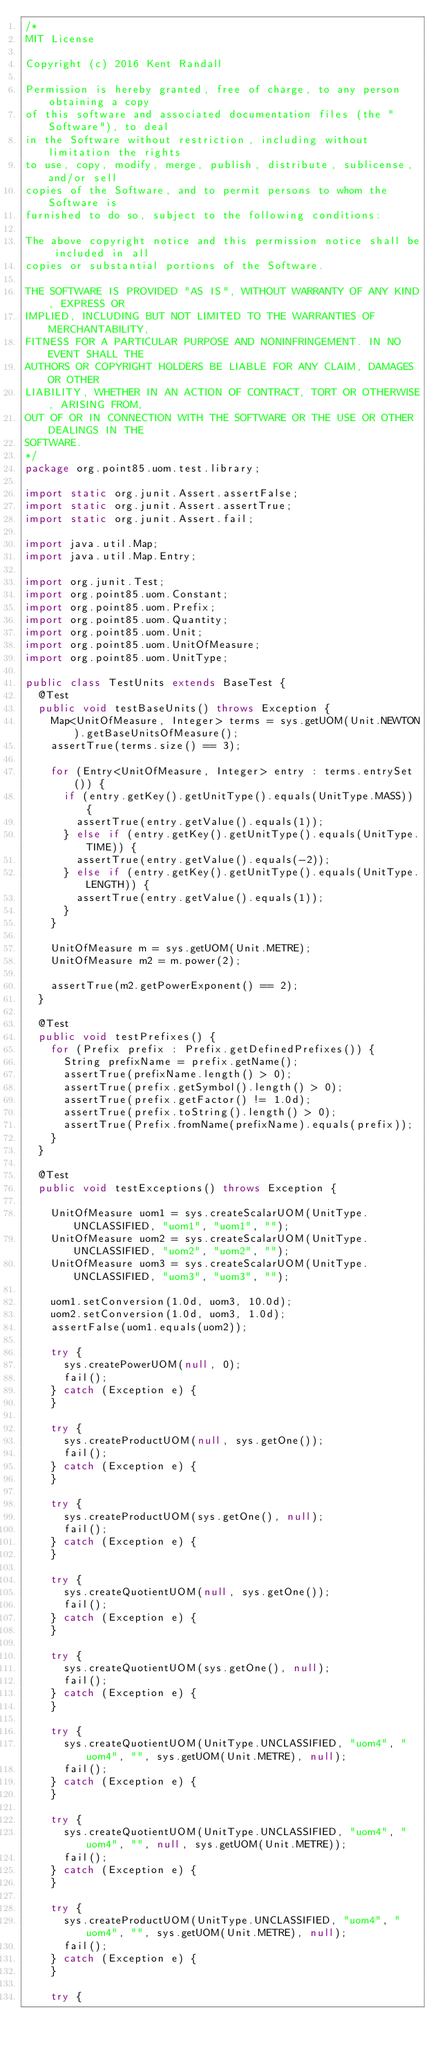Convert code to text. <code><loc_0><loc_0><loc_500><loc_500><_Java_>/*
MIT License

Copyright (c) 2016 Kent Randall

Permission is hereby granted, free of charge, to any person obtaining a copy
of this software and associated documentation files (the "Software"), to deal
in the Software without restriction, including without limitation the rights
to use, copy, modify, merge, publish, distribute, sublicense, and/or sell
copies of the Software, and to permit persons to whom the Software is
furnished to do so, subject to the following conditions:

The above copyright notice and this permission notice shall be included in all
copies or substantial portions of the Software.

THE SOFTWARE IS PROVIDED "AS IS", WITHOUT WARRANTY OF ANY KIND, EXPRESS OR
IMPLIED, INCLUDING BUT NOT LIMITED TO THE WARRANTIES OF MERCHANTABILITY,
FITNESS FOR A PARTICULAR PURPOSE AND NONINFRINGEMENT. IN NO EVENT SHALL THE
AUTHORS OR COPYRIGHT HOLDERS BE LIABLE FOR ANY CLAIM, DAMAGES OR OTHER
LIABILITY, WHETHER IN AN ACTION OF CONTRACT, TORT OR OTHERWISE, ARISING FROM,
OUT OF OR IN CONNECTION WITH THE SOFTWARE OR THE USE OR OTHER DEALINGS IN THE
SOFTWARE.
*/
package org.point85.uom.test.library;

import static org.junit.Assert.assertFalse;
import static org.junit.Assert.assertTrue;
import static org.junit.Assert.fail;

import java.util.Map;
import java.util.Map.Entry;

import org.junit.Test;
import org.point85.uom.Constant;
import org.point85.uom.Prefix;
import org.point85.uom.Quantity;
import org.point85.uom.Unit;
import org.point85.uom.UnitOfMeasure;
import org.point85.uom.UnitType;

public class TestUnits extends BaseTest {
	@Test
	public void testBaseUnits() throws Exception {
		Map<UnitOfMeasure, Integer> terms = sys.getUOM(Unit.NEWTON).getBaseUnitsOfMeasure();
		assertTrue(terms.size() == 3);

		for (Entry<UnitOfMeasure, Integer> entry : terms.entrySet()) {
			if (entry.getKey().getUnitType().equals(UnitType.MASS)) {
				assertTrue(entry.getValue().equals(1));
			} else if (entry.getKey().getUnitType().equals(UnitType.TIME)) {
				assertTrue(entry.getValue().equals(-2));
			} else if (entry.getKey().getUnitType().equals(UnitType.LENGTH)) {
				assertTrue(entry.getValue().equals(1));
			}
		}

		UnitOfMeasure m = sys.getUOM(Unit.METRE);
		UnitOfMeasure m2 = m.power(2);

		assertTrue(m2.getPowerExponent() == 2);
	}

	@Test
	public void testPrefixes() {
		for (Prefix prefix : Prefix.getDefinedPrefixes()) {
			String prefixName = prefix.getName();
			assertTrue(prefixName.length() > 0);
			assertTrue(prefix.getSymbol().length() > 0);
			assertTrue(prefix.getFactor() != 1.0d);
			assertTrue(prefix.toString().length() > 0);
			assertTrue(Prefix.fromName(prefixName).equals(prefix));
		}
	}

	@Test
	public void testExceptions() throws Exception {

		UnitOfMeasure uom1 = sys.createScalarUOM(UnitType.UNCLASSIFIED, "uom1", "uom1", "");
		UnitOfMeasure uom2 = sys.createScalarUOM(UnitType.UNCLASSIFIED, "uom2", "uom2", "");
		UnitOfMeasure uom3 = sys.createScalarUOM(UnitType.UNCLASSIFIED, "uom3", "uom3", "");

		uom1.setConversion(1.0d, uom3, 10.0d);
		uom2.setConversion(1.0d, uom3, 1.0d);
		assertFalse(uom1.equals(uom2));

		try {
			sys.createPowerUOM(null, 0);
			fail();
		} catch (Exception e) {
		}

		try {
			sys.createProductUOM(null, sys.getOne());
			fail();
		} catch (Exception e) {
		}

		try {
			sys.createProductUOM(sys.getOne(), null);
			fail();
		} catch (Exception e) {
		}

		try {
			sys.createQuotientUOM(null, sys.getOne());
			fail();
		} catch (Exception e) {
		}

		try {
			sys.createQuotientUOM(sys.getOne(), null);
			fail();
		} catch (Exception e) {
		}

		try {
			sys.createQuotientUOM(UnitType.UNCLASSIFIED, "uom4", "uom4", "", sys.getUOM(Unit.METRE), null);
			fail();
		} catch (Exception e) {
		}

		try {
			sys.createQuotientUOM(UnitType.UNCLASSIFIED, "uom4", "uom4", "", null, sys.getUOM(Unit.METRE));
			fail();
		} catch (Exception e) {
		}

		try {
			sys.createProductUOM(UnitType.UNCLASSIFIED, "uom4", "uom4", "", sys.getUOM(Unit.METRE), null);
			fail();
		} catch (Exception e) {
		}

		try {</code> 